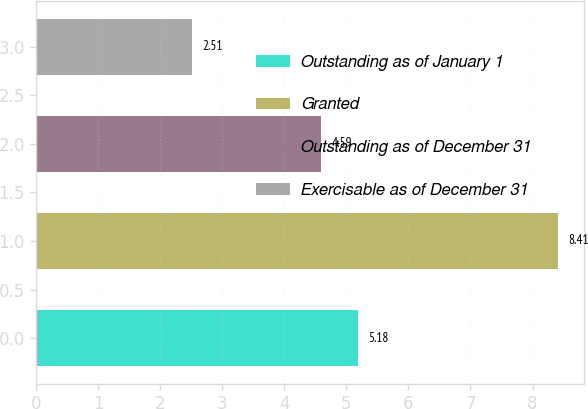Convert chart to OTSL. <chart><loc_0><loc_0><loc_500><loc_500><bar_chart><fcel>Outstanding as of January 1<fcel>Granted<fcel>Outstanding as of December 31<fcel>Exercisable as of December 31<nl><fcel>5.18<fcel>8.41<fcel>4.59<fcel>2.51<nl></chart> 